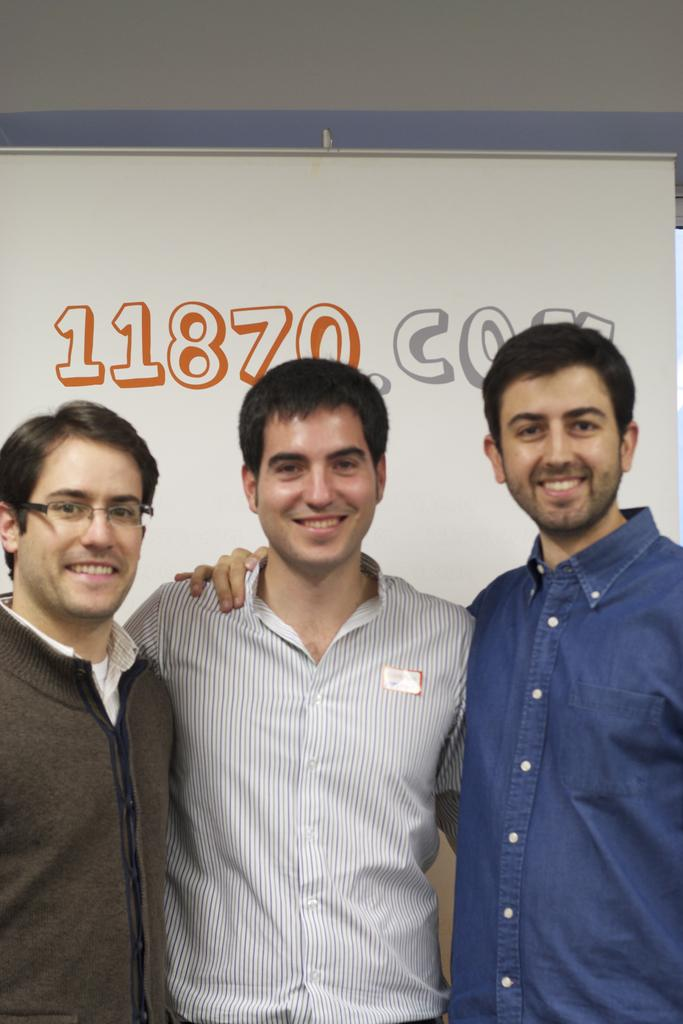How many people are in the image? There are three persons standing in the image. What is the facial expression of the persons in the image? The persons are smiling. What can be seen at the back of the image? There is text visible at the back of the image. What is the number on the board in the image? There is a number on a board in the image. What is the structure at the top of the image? There is a wall at the top of the image. What type of clam is being served on the plate in the image? There is no plate or clam present in the image. How much oatmeal is being consumed by the persons in the image? There is no oatmeal present in the image. 